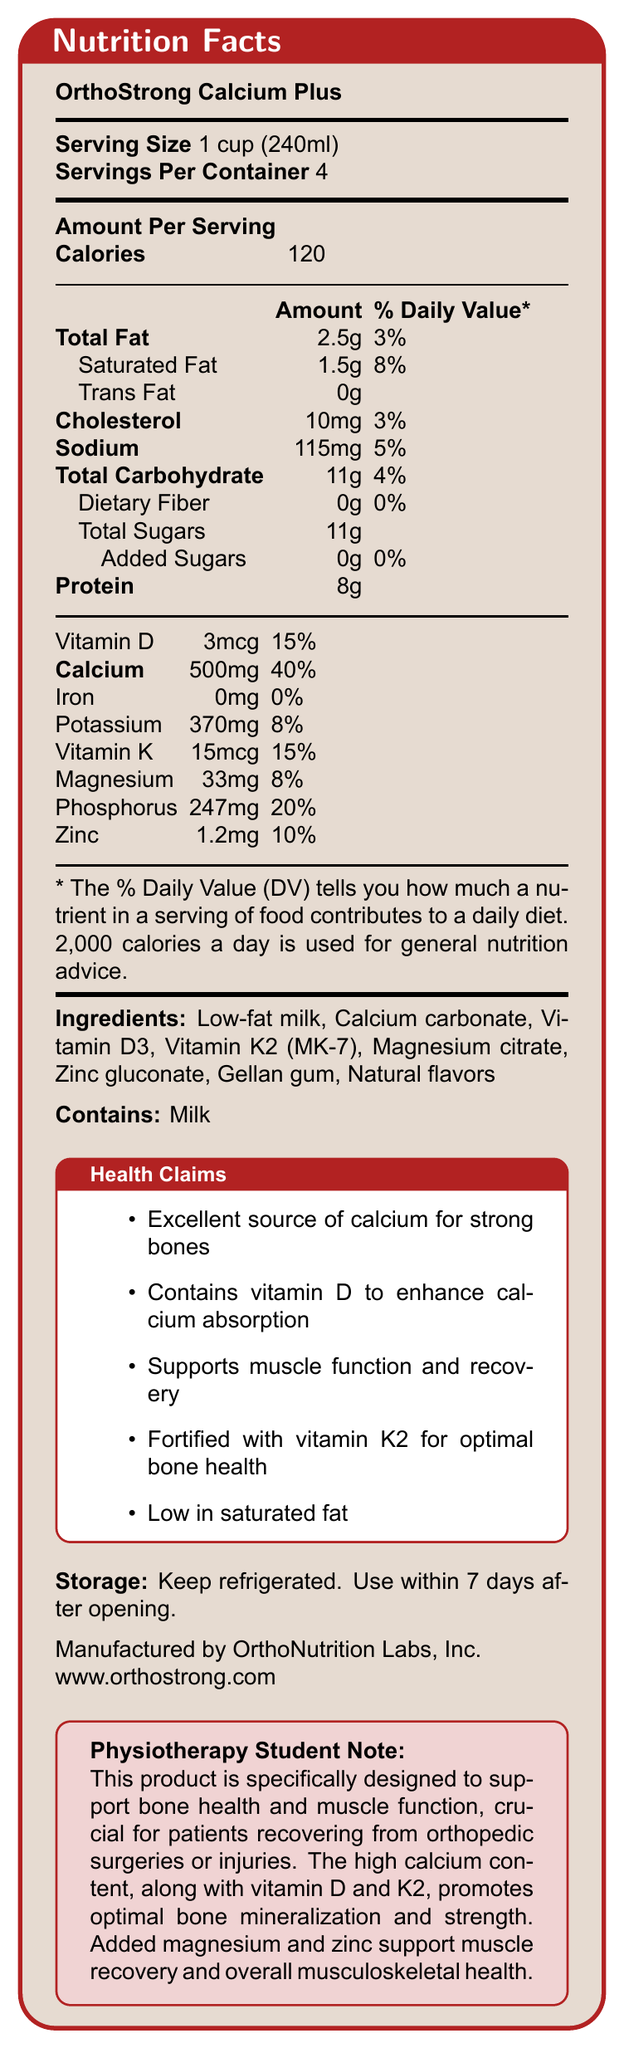what is the serving size? The document states that the serving size is "1 cup (240ml)."
Answer: 1 cup (240ml) how many calories are in one serving of OrthoStrong Calcium Plus? The "Amount Per Serving" section lists the calories as 120.
Answer: 120 what is the amount of protein in each serving? According to the nutrition facts, each serving contains 8g of protein.
Answer: 8g how many servings are in one container? The "Servings Per Container" field indicates there are 4 servings per container.
Answer: 4 what is the percentage of daily value of calcium in each serving? The nutrition information lists calcium as providing 40% of the daily value per serving.
Answer: 40% which vitamin aids in calcium absorption according to the document? The health claims mention that the product contains vitamin D to enhance calcium absorption.
Answer: Vitamin D what ingredient in OrthoStrong Calcium Plus is specifically mentioned to support muscle recovery? A. Vitamin D3 B. Magnesium citrate C. Gellan gum D. Zinc gluconate The physiotherapy student note specifies that magnesium supports muscle recovery.
Answer: B what is the primary health claim about the calcium content in OrthoStrong Calcium Plus? The health claims section states that the product is an excellent source of calcium for strong bones.
Answer: Excellent source of calcium for strong bones what are the percentage daily values of saturated fat and potassium, respectively? A. 8%, 8% B. 10%, 10% C. 8%, 5% D. 3%, 8% Saturated fat has a daily value percentage of 8%, and potassium has a daily value percentage of 8%.
Answer: A is there any fiber in OrthoStrong Calcium Plus? The document lists dietary fiber as 0g, meaning there is no fiber in the product.
Answer: No summarize the main idea of the document. The document's main focus is detailing the nutritional information, ingredients, and health benefits of OrthoStrong Calcium Plus, emphasizing its role in supporting bone health and muscle recovery through high calcium, vitamin D, and vitamin K2 content.
Answer: The document provides the nutrition facts for OrthoStrong Calcium Plus, a calcium-fortified dairy product designed to support bone health and muscle function. It highlights its nutrient content, ingredients, health claims, and storage instructions. what is the percentage of daily value of the added sugars in the product? According to the nutrition facts, the added sugars have a daily value of 0%.
Answer: 0% which mineral in OrthoStrong Calcium Plus has the highest daily value percentage per serving? The document indicates that calcium has the highest daily value percentage at 40%.
Answer: Calcium what flavors are listed in the ingredients? The ingredients section lists "Natural flavors" among the components of the product.
Answer: Natural flavors what is the amount of phosphorus per serving? The nutritional information shows the amount of phosphorus per serving as 247mg.
Answer: 247mg who is the manufacturer of OrthoStrong Calcium Plus? A. OrthoNutrition Labs, Inc. B. Dairy Nutrition Experts, Inc. C. Calcium Plus Nutrition Co. D. Ortho Health Labs, Inc. The document mentions that OrthoStrong Calcium Plus is manufactured by OrthoNutrition Labs, Inc.
Answer: A which vitamins are essential for bone health as stated in the document? The health claims and the physiotherapy student note both emphasize the importance of vitamin D and K2 for bone health.
Answer: Vitamin D and Vitamin K2 how should OrthoStrong Calcium Plus be stored after opening? The storage instructions specify to keep the product refrigerated and use within 7 days after opening.
Answer: Keep refrigerated and use within 7 days after opening. what is the total amount of sugar in one serving? The nutrition facts list total sugars per serving as 11g.
Answer: 11g can the specific source of milk used in OrthoStrong Calcium Plus be identified? The document only lists "Low-fat milk" as an ingredient and does not provide detailed information about the source of the milk.
Answer: Not enough information 